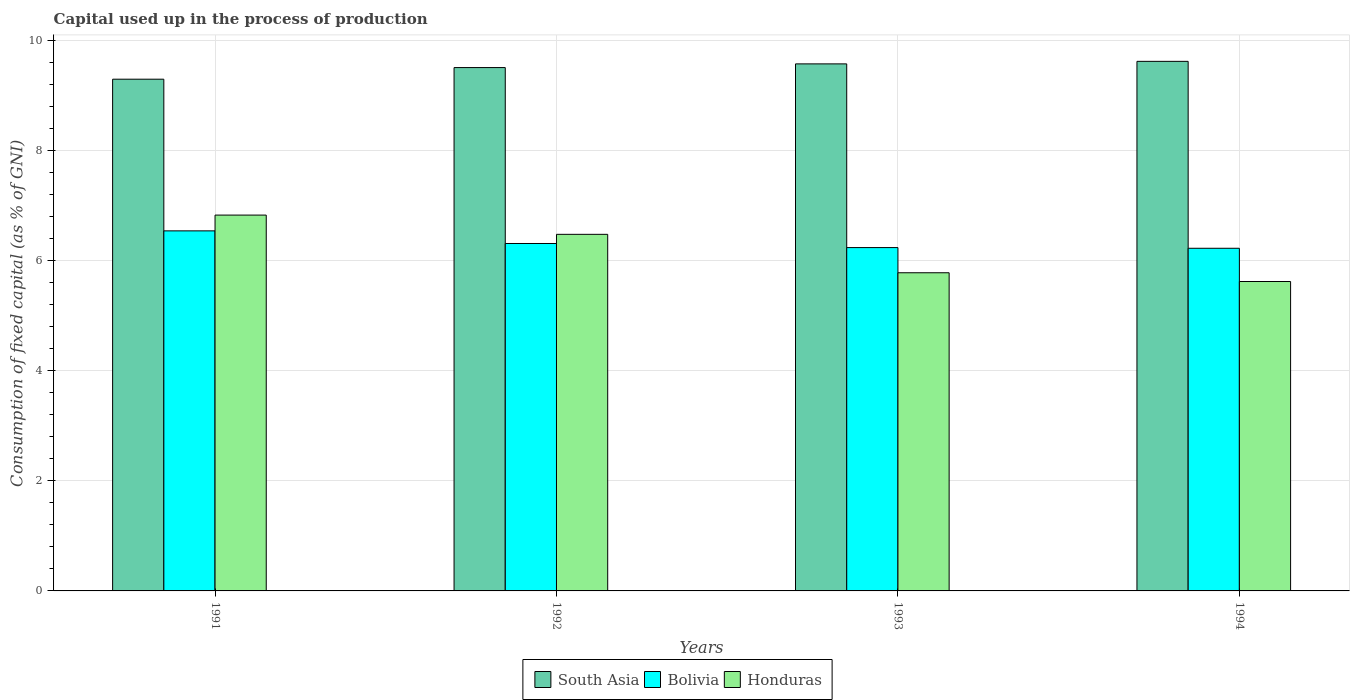Are the number of bars per tick equal to the number of legend labels?
Offer a very short reply. Yes. Are the number of bars on each tick of the X-axis equal?
Your response must be concise. Yes. How many bars are there on the 1st tick from the left?
Keep it short and to the point. 3. How many bars are there on the 2nd tick from the right?
Make the answer very short. 3. What is the label of the 2nd group of bars from the left?
Provide a succinct answer. 1992. In how many cases, is the number of bars for a given year not equal to the number of legend labels?
Offer a terse response. 0. What is the capital used up in the process of production in South Asia in 1992?
Ensure brevity in your answer.  9.51. Across all years, what is the maximum capital used up in the process of production in South Asia?
Your response must be concise. 9.62. Across all years, what is the minimum capital used up in the process of production in South Asia?
Give a very brief answer. 9.3. In which year was the capital used up in the process of production in Bolivia minimum?
Provide a succinct answer. 1994. What is the total capital used up in the process of production in South Asia in the graph?
Provide a short and direct response. 38.01. What is the difference between the capital used up in the process of production in Bolivia in 1991 and that in 1992?
Your response must be concise. 0.23. What is the difference between the capital used up in the process of production in Honduras in 1992 and the capital used up in the process of production in Bolivia in 1993?
Your answer should be very brief. 0.24. What is the average capital used up in the process of production in Honduras per year?
Offer a terse response. 6.18. In the year 1992, what is the difference between the capital used up in the process of production in South Asia and capital used up in the process of production in Bolivia?
Give a very brief answer. 3.2. What is the ratio of the capital used up in the process of production in Honduras in 1991 to that in 1992?
Provide a short and direct response. 1.05. What is the difference between the highest and the second highest capital used up in the process of production in Bolivia?
Offer a terse response. 0.23. What is the difference between the highest and the lowest capital used up in the process of production in Bolivia?
Provide a succinct answer. 0.32. In how many years, is the capital used up in the process of production in Bolivia greater than the average capital used up in the process of production in Bolivia taken over all years?
Provide a short and direct response. 1. Is the sum of the capital used up in the process of production in Bolivia in 1992 and 1994 greater than the maximum capital used up in the process of production in South Asia across all years?
Provide a short and direct response. Yes. What does the 3rd bar from the right in 1993 represents?
Your response must be concise. South Asia. Is it the case that in every year, the sum of the capital used up in the process of production in South Asia and capital used up in the process of production in Honduras is greater than the capital used up in the process of production in Bolivia?
Offer a very short reply. Yes. How many years are there in the graph?
Provide a succinct answer. 4. What is the difference between two consecutive major ticks on the Y-axis?
Your answer should be very brief. 2. Are the values on the major ticks of Y-axis written in scientific E-notation?
Your answer should be compact. No. Where does the legend appear in the graph?
Offer a terse response. Bottom center. How many legend labels are there?
Offer a very short reply. 3. What is the title of the graph?
Provide a short and direct response. Capital used up in the process of production. Does "Equatorial Guinea" appear as one of the legend labels in the graph?
Give a very brief answer. No. What is the label or title of the X-axis?
Provide a succinct answer. Years. What is the label or title of the Y-axis?
Keep it short and to the point. Consumption of fixed capital (as % of GNI). What is the Consumption of fixed capital (as % of GNI) of South Asia in 1991?
Your answer should be compact. 9.3. What is the Consumption of fixed capital (as % of GNI) of Bolivia in 1991?
Provide a short and direct response. 6.54. What is the Consumption of fixed capital (as % of GNI) in Honduras in 1991?
Provide a short and direct response. 6.83. What is the Consumption of fixed capital (as % of GNI) of South Asia in 1992?
Your answer should be compact. 9.51. What is the Consumption of fixed capital (as % of GNI) in Bolivia in 1992?
Make the answer very short. 6.31. What is the Consumption of fixed capital (as % of GNI) of Honduras in 1992?
Provide a succinct answer. 6.48. What is the Consumption of fixed capital (as % of GNI) of South Asia in 1993?
Keep it short and to the point. 9.58. What is the Consumption of fixed capital (as % of GNI) in Bolivia in 1993?
Offer a terse response. 6.24. What is the Consumption of fixed capital (as % of GNI) of Honduras in 1993?
Make the answer very short. 5.78. What is the Consumption of fixed capital (as % of GNI) in South Asia in 1994?
Your answer should be very brief. 9.62. What is the Consumption of fixed capital (as % of GNI) in Bolivia in 1994?
Give a very brief answer. 6.23. What is the Consumption of fixed capital (as % of GNI) of Honduras in 1994?
Offer a very short reply. 5.62. Across all years, what is the maximum Consumption of fixed capital (as % of GNI) in South Asia?
Provide a short and direct response. 9.62. Across all years, what is the maximum Consumption of fixed capital (as % of GNI) of Bolivia?
Your answer should be very brief. 6.54. Across all years, what is the maximum Consumption of fixed capital (as % of GNI) in Honduras?
Your response must be concise. 6.83. Across all years, what is the minimum Consumption of fixed capital (as % of GNI) in South Asia?
Your answer should be compact. 9.3. Across all years, what is the minimum Consumption of fixed capital (as % of GNI) of Bolivia?
Keep it short and to the point. 6.23. Across all years, what is the minimum Consumption of fixed capital (as % of GNI) of Honduras?
Provide a short and direct response. 5.62. What is the total Consumption of fixed capital (as % of GNI) of South Asia in the graph?
Make the answer very short. 38.01. What is the total Consumption of fixed capital (as % of GNI) in Bolivia in the graph?
Your answer should be very brief. 25.32. What is the total Consumption of fixed capital (as % of GNI) of Honduras in the graph?
Make the answer very short. 24.72. What is the difference between the Consumption of fixed capital (as % of GNI) of South Asia in 1991 and that in 1992?
Offer a very short reply. -0.21. What is the difference between the Consumption of fixed capital (as % of GNI) of Bolivia in 1991 and that in 1992?
Provide a succinct answer. 0.23. What is the difference between the Consumption of fixed capital (as % of GNI) of Honduras in 1991 and that in 1992?
Your answer should be compact. 0.35. What is the difference between the Consumption of fixed capital (as % of GNI) in South Asia in 1991 and that in 1993?
Your response must be concise. -0.28. What is the difference between the Consumption of fixed capital (as % of GNI) in Bolivia in 1991 and that in 1993?
Your answer should be very brief. 0.3. What is the difference between the Consumption of fixed capital (as % of GNI) of Honduras in 1991 and that in 1993?
Offer a very short reply. 1.05. What is the difference between the Consumption of fixed capital (as % of GNI) of South Asia in 1991 and that in 1994?
Ensure brevity in your answer.  -0.32. What is the difference between the Consumption of fixed capital (as % of GNI) of Bolivia in 1991 and that in 1994?
Offer a very short reply. 0.32. What is the difference between the Consumption of fixed capital (as % of GNI) of Honduras in 1991 and that in 1994?
Give a very brief answer. 1.21. What is the difference between the Consumption of fixed capital (as % of GNI) in South Asia in 1992 and that in 1993?
Your response must be concise. -0.07. What is the difference between the Consumption of fixed capital (as % of GNI) of Bolivia in 1992 and that in 1993?
Ensure brevity in your answer.  0.07. What is the difference between the Consumption of fixed capital (as % of GNI) in Honduras in 1992 and that in 1993?
Give a very brief answer. 0.7. What is the difference between the Consumption of fixed capital (as % of GNI) of South Asia in 1992 and that in 1994?
Give a very brief answer. -0.11. What is the difference between the Consumption of fixed capital (as % of GNI) in Bolivia in 1992 and that in 1994?
Offer a very short reply. 0.09. What is the difference between the Consumption of fixed capital (as % of GNI) in Honduras in 1992 and that in 1994?
Your answer should be very brief. 0.86. What is the difference between the Consumption of fixed capital (as % of GNI) in South Asia in 1993 and that in 1994?
Make the answer very short. -0.05. What is the difference between the Consumption of fixed capital (as % of GNI) in Bolivia in 1993 and that in 1994?
Give a very brief answer. 0.01. What is the difference between the Consumption of fixed capital (as % of GNI) in Honduras in 1993 and that in 1994?
Ensure brevity in your answer.  0.16. What is the difference between the Consumption of fixed capital (as % of GNI) of South Asia in 1991 and the Consumption of fixed capital (as % of GNI) of Bolivia in 1992?
Your answer should be very brief. 2.99. What is the difference between the Consumption of fixed capital (as % of GNI) in South Asia in 1991 and the Consumption of fixed capital (as % of GNI) in Honduras in 1992?
Your response must be concise. 2.82. What is the difference between the Consumption of fixed capital (as % of GNI) of Bolivia in 1991 and the Consumption of fixed capital (as % of GNI) of Honduras in 1992?
Your answer should be compact. 0.06. What is the difference between the Consumption of fixed capital (as % of GNI) of South Asia in 1991 and the Consumption of fixed capital (as % of GNI) of Bolivia in 1993?
Your answer should be compact. 3.06. What is the difference between the Consumption of fixed capital (as % of GNI) of South Asia in 1991 and the Consumption of fixed capital (as % of GNI) of Honduras in 1993?
Your answer should be compact. 3.52. What is the difference between the Consumption of fixed capital (as % of GNI) of Bolivia in 1991 and the Consumption of fixed capital (as % of GNI) of Honduras in 1993?
Make the answer very short. 0.76. What is the difference between the Consumption of fixed capital (as % of GNI) in South Asia in 1991 and the Consumption of fixed capital (as % of GNI) in Bolivia in 1994?
Give a very brief answer. 3.07. What is the difference between the Consumption of fixed capital (as % of GNI) of South Asia in 1991 and the Consumption of fixed capital (as % of GNI) of Honduras in 1994?
Ensure brevity in your answer.  3.68. What is the difference between the Consumption of fixed capital (as % of GNI) of Bolivia in 1991 and the Consumption of fixed capital (as % of GNI) of Honduras in 1994?
Give a very brief answer. 0.92. What is the difference between the Consumption of fixed capital (as % of GNI) in South Asia in 1992 and the Consumption of fixed capital (as % of GNI) in Bolivia in 1993?
Offer a terse response. 3.27. What is the difference between the Consumption of fixed capital (as % of GNI) of South Asia in 1992 and the Consumption of fixed capital (as % of GNI) of Honduras in 1993?
Offer a very short reply. 3.73. What is the difference between the Consumption of fixed capital (as % of GNI) of Bolivia in 1992 and the Consumption of fixed capital (as % of GNI) of Honduras in 1993?
Provide a succinct answer. 0.53. What is the difference between the Consumption of fixed capital (as % of GNI) in South Asia in 1992 and the Consumption of fixed capital (as % of GNI) in Bolivia in 1994?
Give a very brief answer. 3.28. What is the difference between the Consumption of fixed capital (as % of GNI) of South Asia in 1992 and the Consumption of fixed capital (as % of GNI) of Honduras in 1994?
Your answer should be compact. 3.89. What is the difference between the Consumption of fixed capital (as % of GNI) in Bolivia in 1992 and the Consumption of fixed capital (as % of GNI) in Honduras in 1994?
Ensure brevity in your answer.  0.69. What is the difference between the Consumption of fixed capital (as % of GNI) of South Asia in 1993 and the Consumption of fixed capital (as % of GNI) of Bolivia in 1994?
Offer a very short reply. 3.35. What is the difference between the Consumption of fixed capital (as % of GNI) in South Asia in 1993 and the Consumption of fixed capital (as % of GNI) in Honduras in 1994?
Ensure brevity in your answer.  3.96. What is the difference between the Consumption of fixed capital (as % of GNI) in Bolivia in 1993 and the Consumption of fixed capital (as % of GNI) in Honduras in 1994?
Ensure brevity in your answer.  0.62. What is the average Consumption of fixed capital (as % of GNI) in South Asia per year?
Ensure brevity in your answer.  9.5. What is the average Consumption of fixed capital (as % of GNI) in Bolivia per year?
Give a very brief answer. 6.33. What is the average Consumption of fixed capital (as % of GNI) of Honduras per year?
Ensure brevity in your answer.  6.18. In the year 1991, what is the difference between the Consumption of fixed capital (as % of GNI) in South Asia and Consumption of fixed capital (as % of GNI) in Bolivia?
Your response must be concise. 2.76. In the year 1991, what is the difference between the Consumption of fixed capital (as % of GNI) of South Asia and Consumption of fixed capital (as % of GNI) of Honduras?
Ensure brevity in your answer.  2.47. In the year 1991, what is the difference between the Consumption of fixed capital (as % of GNI) of Bolivia and Consumption of fixed capital (as % of GNI) of Honduras?
Make the answer very short. -0.29. In the year 1992, what is the difference between the Consumption of fixed capital (as % of GNI) in South Asia and Consumption of fixed capital (as % of GNI) in Bolivia?
Offer a very short reply. 3.2. In the year 1992, what is the difference between the Consumption of fixed capital (as % of GNI) in South Asia and Consumption of fixed capital (as % of GNI) in Honduras?
Your answer should be very brief. 3.03. In the year 1992, what is the difference between the Consumption of fixed capital (as % of GNI) of Bolivia and Consumption of fixed capital (as % of GNI) of Honduras?
Offer a very short reply. -0.17. In the year 1993, what is the difference between the Consumption of fixed capital (as % of GNI) of South Asia and Consumption of fixed capital (as % of GNI) of Bolivia?
Provide a short and direct response. 3.34. In the year 1993, what is the difference between the Consumption of fixed capital (as % of GNI) in South Asia and Consumption of fixed capital (as % of GNI) in Honduras?
Your answer should be compact. 3.8. In the year 1993, what is the difference between the Consumption of fixed capital (as % of GNI) of Bolivia and Consumption of fixed capital (as % of GNI) of Honduras?
Give a very brief answer. 0.46. In the year 1994, what is the difference between the Consumption of fixed capital (as % of GNI) of South Asia and Consumption of fixed capital (as % of GNI) of Bolivia?
Ensure brevity in your answer.  3.4. In the year 1994, what is the difference between the Consumption of fixed capital (as % of GNI) of South Asia and Consumption of fixed capital (as % of GNI) of Honduras?
Provide a succinct answer. 4. In the year 1994, what is the difference between the Consumption of fixed capital (as % of GNI) of Bolivia and Consumption of fixed capital (as % of GNI) of Honduras?
Your answer should be compact. 0.6. What is the ratio of the Consumption of fixed capital (as % of GNI) of South Asia in 1991 to that in 1992?
Offer a very short reply. 0.98. What is the ratio of the Consumption of fixed capital (as % of GNI) in Bolivia in 1991 to that in 1992?
Give a very brief answer. 1.04. What is the ratio of the Consumption of fixed capital (as % of GNI) of Honduras in 1991 to that in 1992?
Keep it short and to the point. 1.05. What is the ratio of the Consumption of fixed capital (as % of GNI) of South Asia in 1991 to that in 1993?
Your answer should be very brief. 0.97. What is the ratio of the Consumption of fixed capital (as % of GNI) in Bolivia in 1991 to that in 1993?
Offer a terse response. 1.05. What is the ratio of the Consumption of fixed capital (as % of GNI) in Honduras in 1991 to that in 1993?
Your answer should be compact. 1.18. What is the ratio of the Consumption of fixed capital (as % of GNI) in South Asia in 1991 to that in 1994?
Give a very brief answer. 0.97. What is the ratio of the Consumption of fixed capital (as % of GNI) in Bolivia in 1991 to that in 1994?
Give a very brief answer. 1.05. What is the ratio of the Consumption of fixed capital (as % of GNI) of Honduras in 1991 to that in 1994?
Make the answer very short. 1.21. What is the ratio of the Consumption of fixed capital (as % of GNI) in South Asia in 1992 to that in 1993?
Offer a terse response. 0.99. What is the ratio of the Consumption of fixed capital (as % of GNI) of Bolivia in 1992 to that in 1993?
Offer a terse response. 1.01. What is the ratio of the Consumption of fixed capital (as % of GNI) in Honduras in 1992 to that in 1993?
Your answer should be compact. 1.12. What is the ratio of the Consumption of fixed capital (as % of GNI) in South Asia in 1992 to that in 1994?
Offer a terse response. 0.99. What is the ratio of the Consumption of fixed capital (as % of GNI) in Bolivia in 1992 to that in 1994?
Make the answer very short. 1.01. What is the ratio of the Consumption of fixed capital (as % of GNI) of Honduras in 1992 to that in 1994?
Give a very brief answer. 1.15. What is the ratio of the Consumption of fixed capital (as % of GNI) of South Asia in 1993 to that in 1994?
Give a very brief answer. 1. What is the ratio of the Consumption of fixed capital (as % of GNI) of Bolivia in 1993 to that in 1994?
Offer a terse response. 1. What is the ratio of the Consumption of fixed capital (as % of GNI) in Honduras in 1993 to that in 1994?
Your answer should be compact. 1.03. What is the difference between the highest and the second highest Consumption of fixed capital (as % of GNI) of South Asia?
Provide a succinct answer. 0.05. What is the difference between the highest and the second highest Consumption of fixed capital (as % of GNI) in Bolivia?
Your answer should be compact. 0.23. What is the difference between the highest and the second highest Consumption of fixed capital (as % of GNI) of Honduras?
Make the answer very short. 0.35. What is the difference between the highest and the lowest Consumption of fixed capital (as % of GNI) in South Asia?
Keep it short and to the point. 0.32. What is the difference between the highest and the lowest Consumption of fixed capital (as % of GNI) in Bolivia?
Offer a terse response. 0.32. What is the difference between the highest and the lowest Consumption of fixed capital (as % of GNI) of Honduras?
Keep it short and to the point. 1.21. 